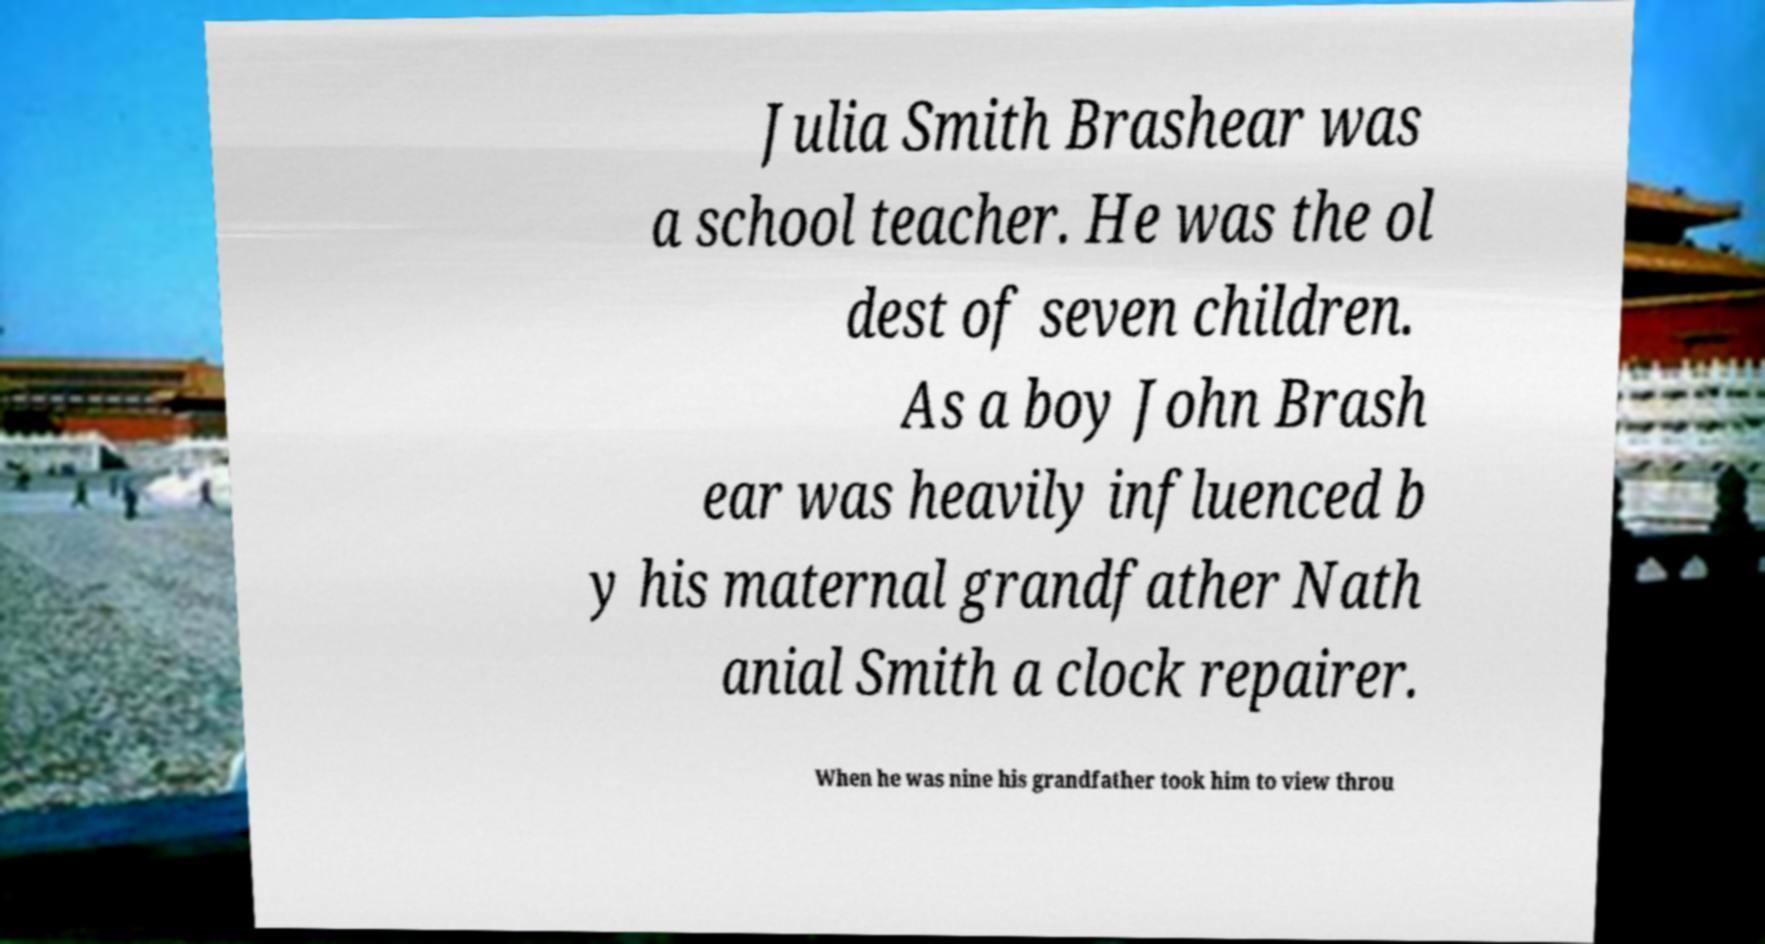There's text embedded in this image that I need extracted. Can you transcribe it verbatim? Julia Smith Brashear was a school teacher. He was the ol dest of seven children. As a boy John Brash ear was heavily influenced b y his maternal grandfather Nath anial Smith a clock repairer. When he was nine his grandfather took him to view throu 